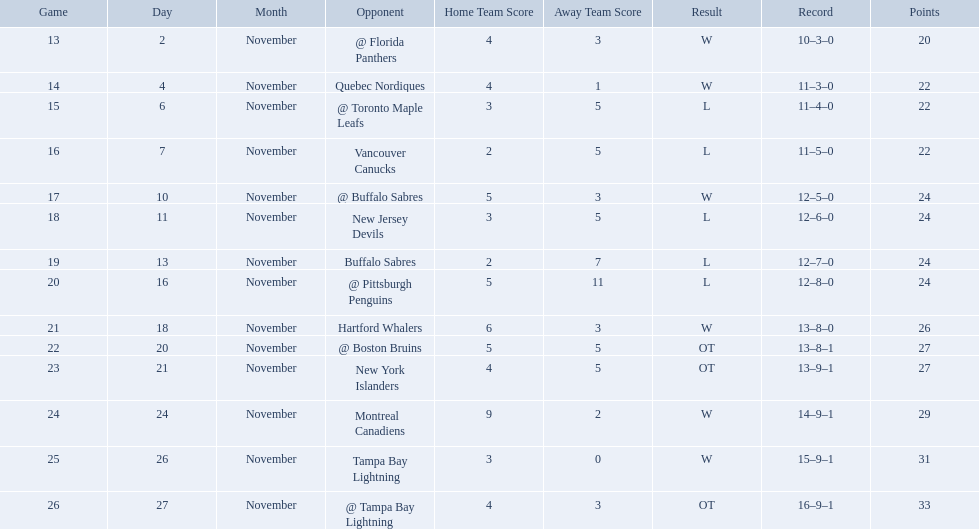Who did the philadelphia flyers play in game 17? @ Buffalo Sabres. What was the score of the november 10th game against the buffalo sabres? 5–3. Which team in the atlantic division had less points than the philadelphia flyers? Tampa Bay Lightning. What are the teams in the atlantic division? Quebec Nordiques, Vancouver Canucks, New Jersey Devils, Buffalo Sabres, Hartford Whalers, New York Islanders, Montreal Canadiens, Tampa Bay Lightning. Which of those scored fewer points than the philadelphia flyers? Tampa Bay Lightning. What were the scores? @ Florida Panthers, 4–3, Quebec Nordiques, 4–1, @ Toronto Maple Leafs, 3–5, Vancouver Canucks, 2–5, @ Buffalo Sabres, 5–3, New Jersey Devils, 3–5, Buffalo Sabres, 2–7, @ Pittsburgh Penguins, 5–11, Hartford Whalers, 6–3, @ Boston Bruins, 5–5 OT, New York Islanders, 4–5 OT, Montreal Canadiens, 9–2, Tampa Bay Lightning, 3–0, @ Tampa Bay Lightning, 4–3 OT. What score was the closest? New York Islanders, 4–5 OT. What team had that score? New York Islanders. 